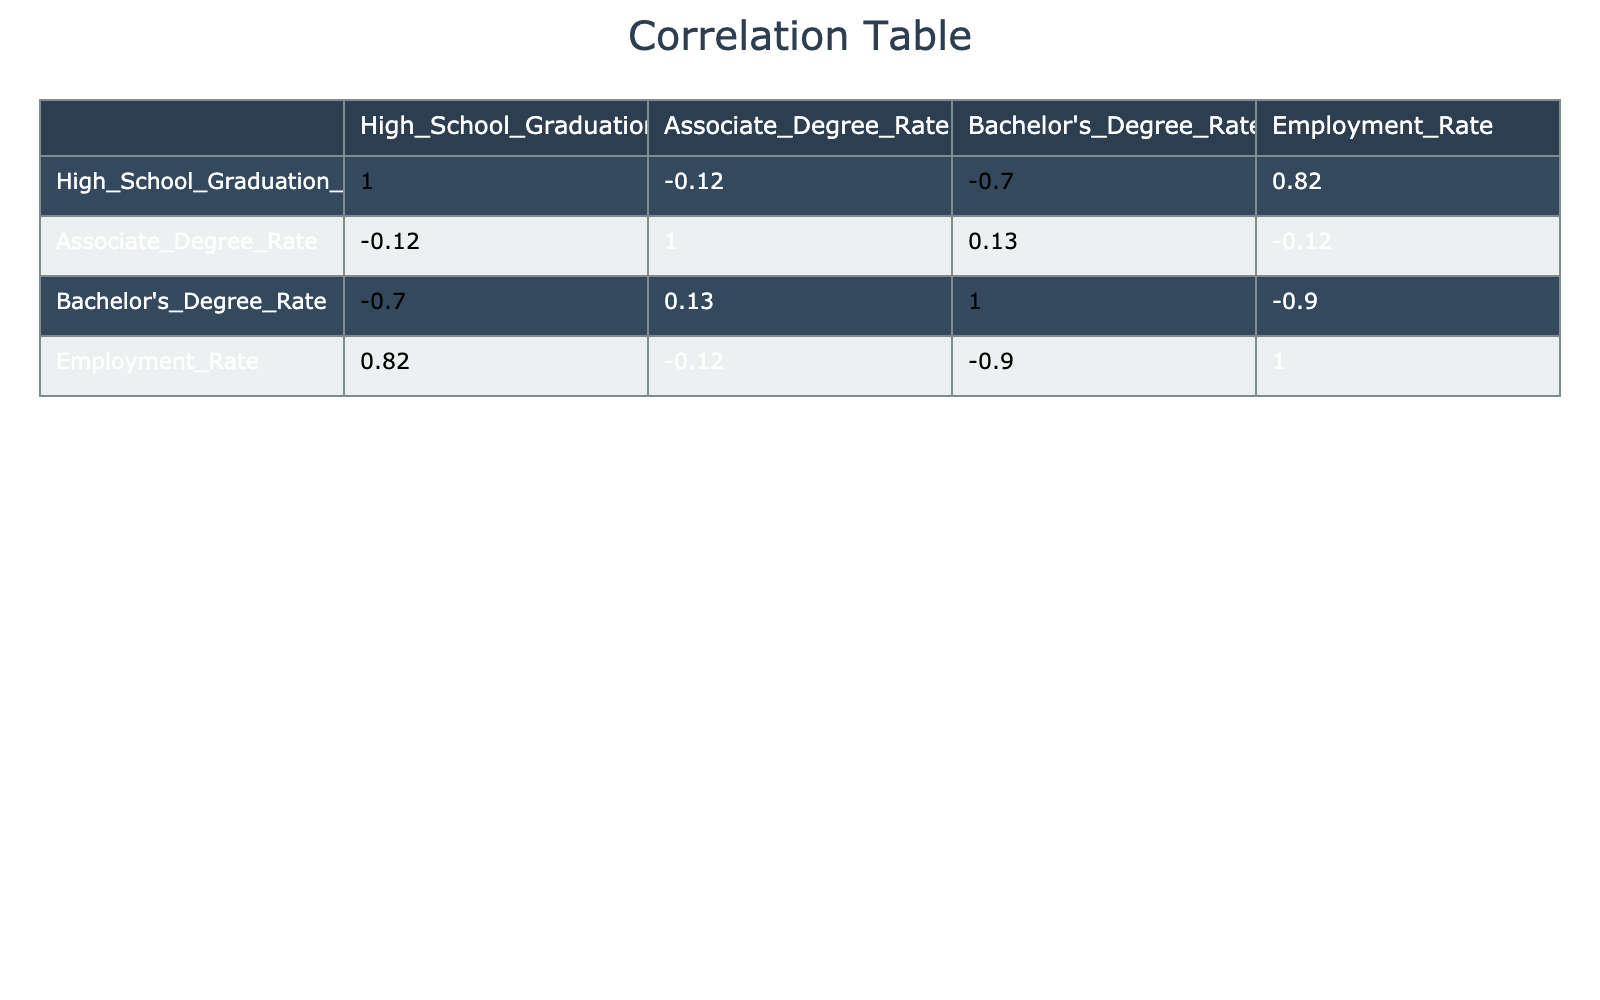What is the employment rate for Riverside? The table shows that the employment rate for Riverside is explicitly listed in the fourth column of its respective row.
Answer: 88 Which district has the highest Bachelor’s degree rate? By examining the Bachelor's Degree Rate column, we can see the maximum value, which belongs to Westwood at 50.
Answer: Westwood What is the correlation between High School Graduation Rate and Employment Rate? Looking at the correlation table, we find the values in the respective column rows. The correlation coefficient between High School Graduation Rate and Employment Rate is 0.85.
Answer: 0.85 Which districts have an Employment Rate greater than 90%? We check the Employment Rate column to identify the districts exceeding 90%. The districts that meet this criterion are Springfield and Mapleton.
Answer: Springfield, Mapleton Calculate the average Associate Degree Rate among all districts. To find the average, we add all Associate Degree Rates (45 + 50 + 40 + 55 + 60 + 50 + 48 + 35 + 42 + 56 =  478) and divide by the total number of districts (10), resulting in 47.8.
Answer: 47.8 Is the Bachelor's Degree Rate higher in Greenwood or Lakeside? By comparing the entries in the Bachelor's Degree Rate column for Greenwood (45) and Lakeside (25), we can determine that Greenwood has the higher rate.
Answer: Yes Which district has the lowest employment rate and what is that rate? By scanning the Employment Rate column, we identify that Westwood has the lowest employment rate at 80.
Answer: 80 What is the difference in Employment Rate between districts with the highest and lowest High School Graduation Rate? The highest High School Graduation Rate is in Springfield (95) and the lowest is in Hilltop (80). Their respective Employment Rates are 92 for Springfield and 83 for Hilltop, so the difference is 92 - 83 = 9.
Answer: 9 What is the total number of districts with an Associate Degree Rate below 50%? We need to count the districts in the Associate Degree Rate column that are below 50%. The eligible districts are Metroville, Clearwater, and Brookfield. Therefore, there are three districts.
Answer: 3 